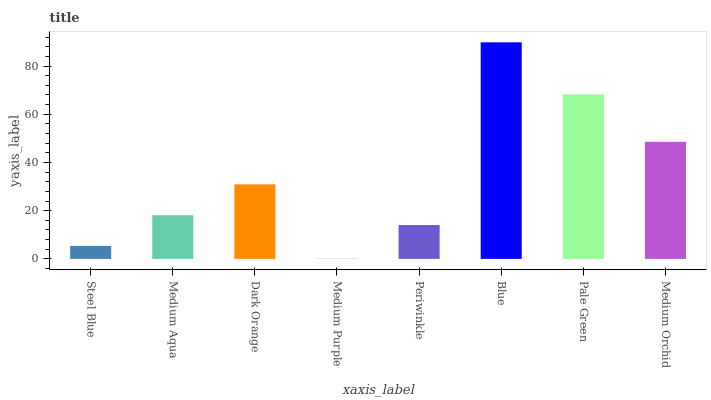Is Medium Purple the minimum?
Answer yes or no. Yes. Is Blue the maximum?
Answer yes or no. Yes. Is Medium Aqua the minimum?
Answer yes or no. No. Is Medium Aqua the maximum?
Answer yes or no. No. Is Medium Aqua greater than Steel Blue?
Answer yes or no. Yes. Is Steel Blue less than Medium Aqua?
Answer yes or no. Yes. Is Steel Blue greater than Medium Aqua?
Answer yes or no. No. Is Medium Aqua less than Steel Blue?
Answer yes or no. No. Is Dark Orange the high median?
Answer yes or no. Yes. Is Medium Aqua the low median?
Answer yes or no. Yes. Is Medium Orchid the high median?
Answer yes or no. No. Is Pale Green the low median?
Answer yes or no. No. 